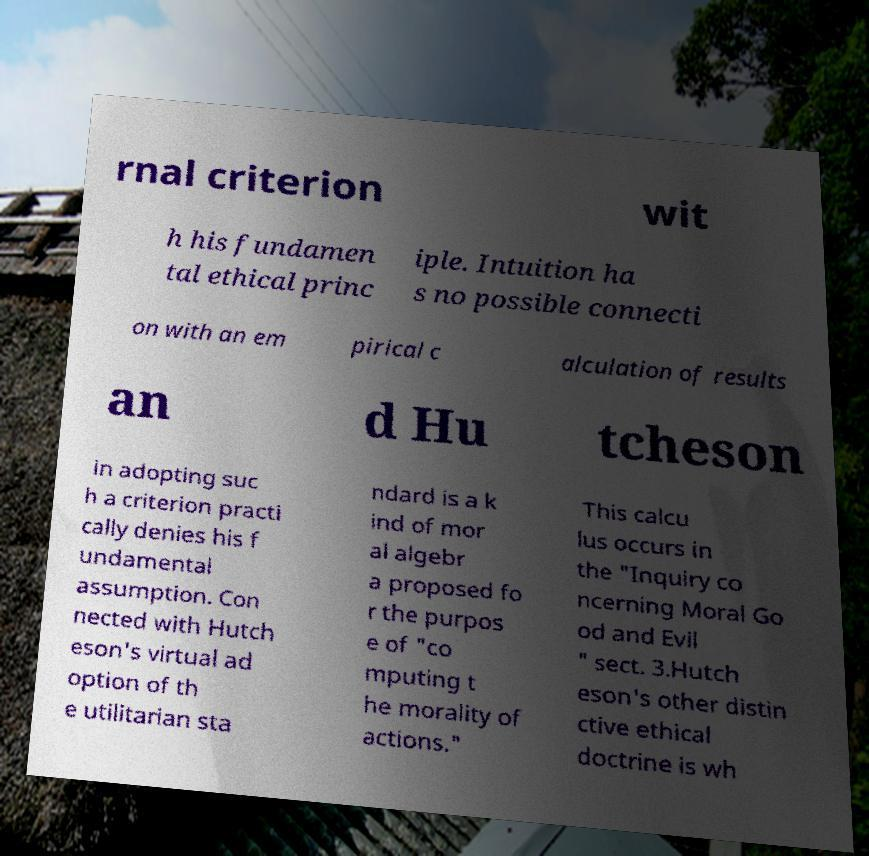Can you accurately transcribe the text from the provided image for me? rnal criterion wit h his fundamen tal ethical princ iple. Intuition ha s no possible connecti on with an em pirical c alculation of results an d Hu tcheson in adopting suc h a criterion practi cally denies his f undamental assumption. Con nected with Hutch eson's virtual ad option of th e utilitarian sta ndard is a k ind of mor al algebr a proposed fo r the purpos e of "co mputing t he morality of actions." This calcu lus occurs in the "Inquiry co ncerning Moral Go od and Evil " sect. 3.Hutch eson's other distin ctive ethical doctrine is wh 